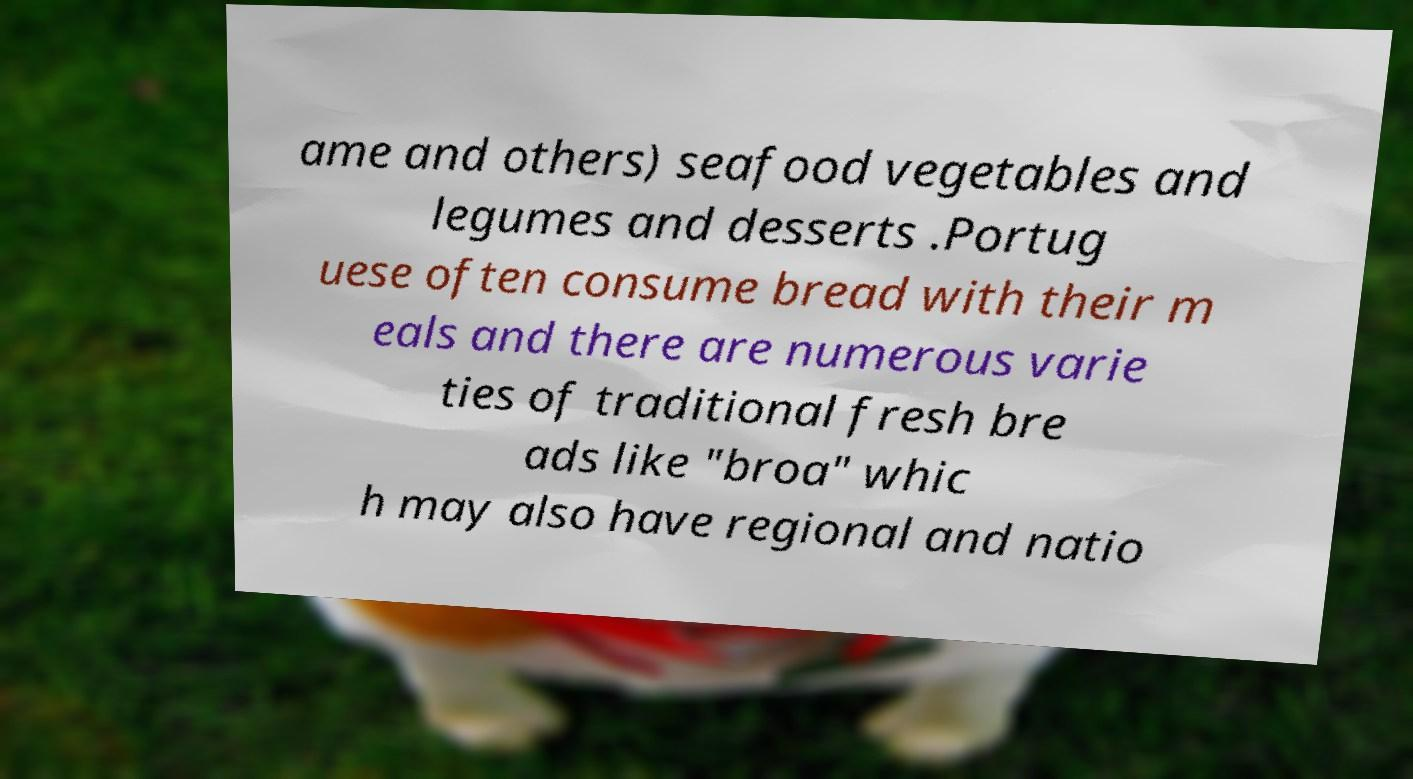Can you read and provide the text displayed in the image?This photo seems to have some interesting text. Can you extract and type it out for me? ame and others) seafood vegetables and legumes and desserts .Portug uese often consume bread with their m eals and there are numerous varie ties of traditional fresh bre ads like "broa" whic h may also have regional and natio 